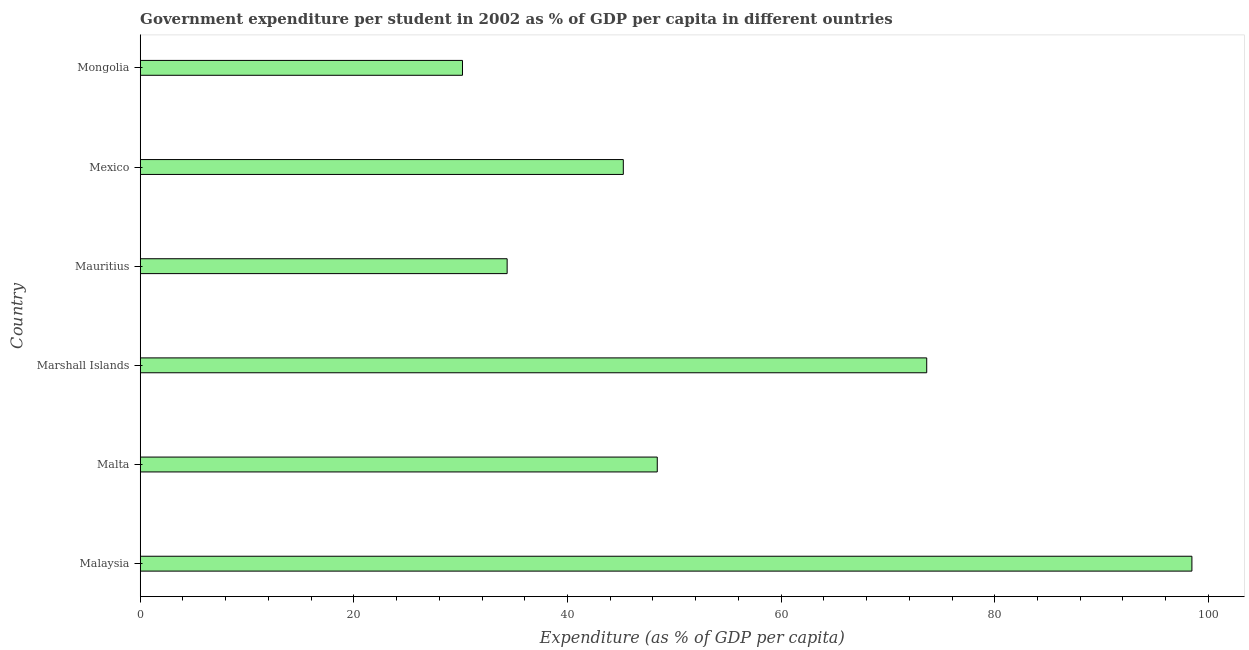Does the graph contain any zero values?
Keep it short and to the point. No. What is the title of the graph?
Your answer should be very brief. Government expenditure per student in 2002 as % of GDP per capita in different ountries. What is the label or title of the X-axis?
Ensure brevity in your answer.  Expenditure (as % of GDP per capita). What is the government expenditure per student in Mexico?
Offer a terse response. 45.23. Across all countries, what is the maximum government expenditure per student?
Provide a succinct answer. 98.46. Across all countries, what is the minimum government expenditure per student?
Provide a succinct answer. 30.17. In which country was the government expenditure per student maximum?
Provide a short and direct response. Malaysia. In which country was the government expenditure per student minimum?
Offer a terse response. Mongolia. What is the sum of the government expenditure per student?
Make the answer very short. 330.24. What is the difference between the government expenditure per student in Marshall Islands and Mauritius?
Your answer should be compact. 39.28. What is the average government expenditure per student per country?
Keep it short and to the point. 55.04. What is the median government expenditure per student?
Your response must be concise. 46.82. What is the ratio of the government expenditure per student in Mauritius to that in Mongolia?
Your answer should be very brief. 1.14. Is the difference between the government expenditure per student in Malaysia and Mauritius greater than the difference between any two countries?
Provide a succinct answer. No. What is the difference between the highest and the second highest government expenditure per student?
Your answer should be very brief. 24.83. What is the difference between the highest and the lowest government expenditure per student?
Ensure brevity in your answer.  68.29. Are all the bars in the graph horizontal?
Provide a succinct answer. Yes. How many countries are there in the graph?
Offer a very short reply. 6. What is the Expenditure (as % of GDP per capita) in Malaysia?
Your answer should be compact. 98.46. What is the Expenditure (as % of GDP per capita) of Malta?
Your response must be concise. 48.41. What is the Expenditure (as % of GDP per capita) of Marshall Islands?
Offer a terse response. 73.63. What is the Expenditure (as % of GDP per capita) of Mauritius?
Keep it short and to the point. 34.35. What is the Expenditure (as % of GDP per capita) of Mexico?
Your answer should be compact. 45.23. What is the Expenditure (as % of GDP per capita) in Mongolia?
Your response must be concise. 30.17. What is the difference between the Expenditure (as % of GDP per capita) in Malaysia and Malta?
Provide a succinct answer. 50.05. What is the difference between the Expenditure (as % of GDP per capita) in Malaysia and Marshall Islands?
Provide a short and direct response. 24.83. What is the difference between the Expenditure (as % of GDP per capita) in Malaysia and Mauritius?
Your answer should be very brief. 64.11. What is the difference between the Expenditure (as % of GDP per capita) in Malaysia and Mexico?
Offer a terse response. 53.23. What is the difference between the Expenditure (as % of GDP per capita) in Malaysia and Mongolia?
Your response must be concise. 68.29. What is the difference between the Expenditure (as % of GDP per capita) in Malta and Marshall Islands?
Your response must be concise. -25.23. What is the difference between the Expenditure (as % of GDP per capita) in Malta and Mauritius?
Offer a terse response. 14.06. What is the difference between the Expenditure (as % of GDP per capita) in Malta and Mexico?
Your answer should be very brief. 3.18. What is the difference between the Expenditure (as % of GDP per capita) in Malta and Mongolia?
Your answer should be very brief. 18.24. What is the difference between the Expenditure (as % of GDP per capita) in Marshall Islands and Mauritius?
Your answer should be compact. 39.28. What is the difference between the Expenditure (as % of GDP per capita) in Marshall Islands and Mexico?
Provide a succinct answer. 28.41. What is the difference between the Expenditure (as % of GDP per capita) in Marshall Islands and Mongolia?
Ensure brevity in your answer.  43.46. What is the difference between the Expenditure (as % of GDP per capita) in Mauritius and Mexico?
Provide a short and direct response. -10.88. What is the difference between the Expenditure (as % of GDP per capita) in Mauritius and Mongolia?
Offer a terse response. 4.18. What is the difference between the Expenditure (as % of GDP per capita) in Mexico and Mongolia?
Offer a very short reply. 15.06. What is the ratio of the Expenditure (as % of GDP per capita) in Malaysia to that in Malta?
Provide a succinct answer. 2.03. What is the ratio of the Expenditure (as % of GDP per capita) in Malaysia to that in Marshall Islands?
Provide a succinct answer. 1.34. What is the ratio of the Expenditure (as % of GDP per capita) in Malaysia to that in Mauritius?
Offer a terse response. 2.87. What is the ratio of the Expenditure (as % of GDP per capita) in Malaysia to that in Mexico?
Keep it short and to the point. 2.18. What is the ratio of the Expenditure (as % of GDP per capita) in Malaysia to that in Mongolia?
Your response must be concise. 3.26. What is the ratio of the Expenditure (as % of GDP per capita) in Malta to that in Marshall Islands?
Keep it short and to the point. 0.66. What is the ratio of the Expenditure (as % of GDP per capita) in Malta to that in Mauritius?
Ensure brevity in your answer.  1.41. What is the ratio of the Expenditure (as % of GDP per capita) in Malta to that in Mexico?
Your response must be concise. 1.07. What is the ratio of the Expenditure (as % of GDP per capita) in Malta to that in Mongolia?
Your answer should be compact. 1.6. What is the ratio of the Expenditure (as % of GDP per capita) in Marshall Islands to that in Mauritius?
Offer a terse response. 2.14. What is the ratio of the Expenditure (as % of GDP per capita) in Marshall Islands to that in Mexico?
Offer a terse response. 1.63. What is the ratio of the Expenditure (as % of GDP per capita) in Marshall Islands to that in Mongolia?
Give a very brief answer. 2.44. What is the ratio of the Expenditure (as % of GDP per capita) in Mauritius to that in Mexico?
Offer a terse response. 0.76. What is the ratio of the Expenditure (as % of GDP per capita) in Mauritius to that in Mongolia?
Give a very brief answer. 1.14. What is the ratio of the Expenditure (as % of GDP per capita) in Mexico to that in Mongolia?
Make the answer very short. 1.5. 